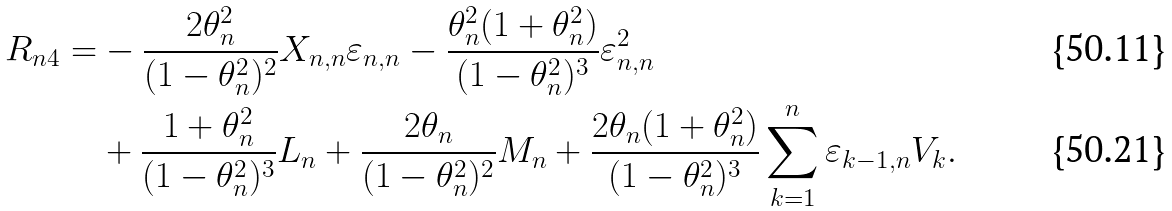<formula> <loc_0><loc_0><loc_500><loc_500>R _ { n 4 } = & - \frac { 2 \theta _ { n } ^ { 2 } } { ( 1 - \theta _ { n } ^ { 2 } ) ^ { 2 } } X _ { n , n } \varepsilon _ { n , n } - \frac { \theta _ { n } ^ { 2 } ( 1 + \theta _ { n } ^ { 2 } ) } { ( 1 - \theta _ { n } ^ { 2 } ) ^ { 3 } } \varepsilon _ { n , n } ^ { 2 } \\ & + \frac { 1 + \theta _ { n } ^ { 2 } } { ( 1 - \theta _ { n } ^ { 2 } ) ^ { 3 } } L _ { n } + \frac { 2 \theta _ { n } } { ( 1 - \theta _ { n } ^ { 2 } ) ^ { 2 } } M _ { n } + \frac { 2 \theta _ { n } ( 1 + \theta _ { n } ^ { 2 } ) } { ( 1 - \theta _ { n } ^ { 2 } ) ^ { 3 } } \sum _ { k = 1 } ^ { n } { \varepsilon _ { k - 1 , n } V _ { k } } .</formula> 